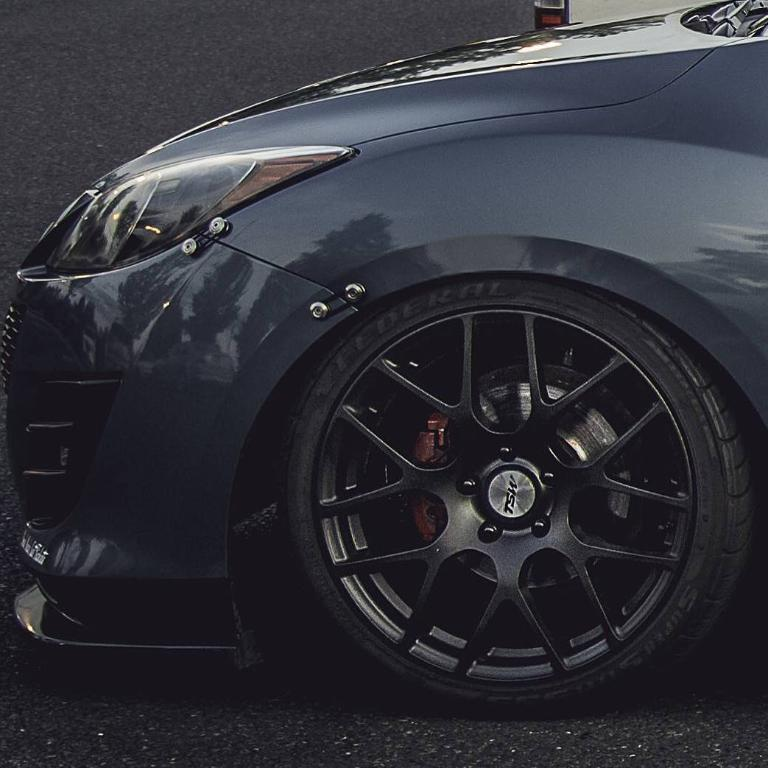What type of vehicle is in the image? There is a black color car in the image. Where is the car located in the image? The car is at the front part of the image. What surface is the car on in the image? The car is on the road in the image. What type of business is being conducted in the image? There is no indication of a business being conducted in the image; it features a black color car on the road. How many things can be seen in the image? It is not clear what "things" refers to in this context, but the image primarily features a black color car on the road. Can you see a goose in the image? There is no goose present in the image. 